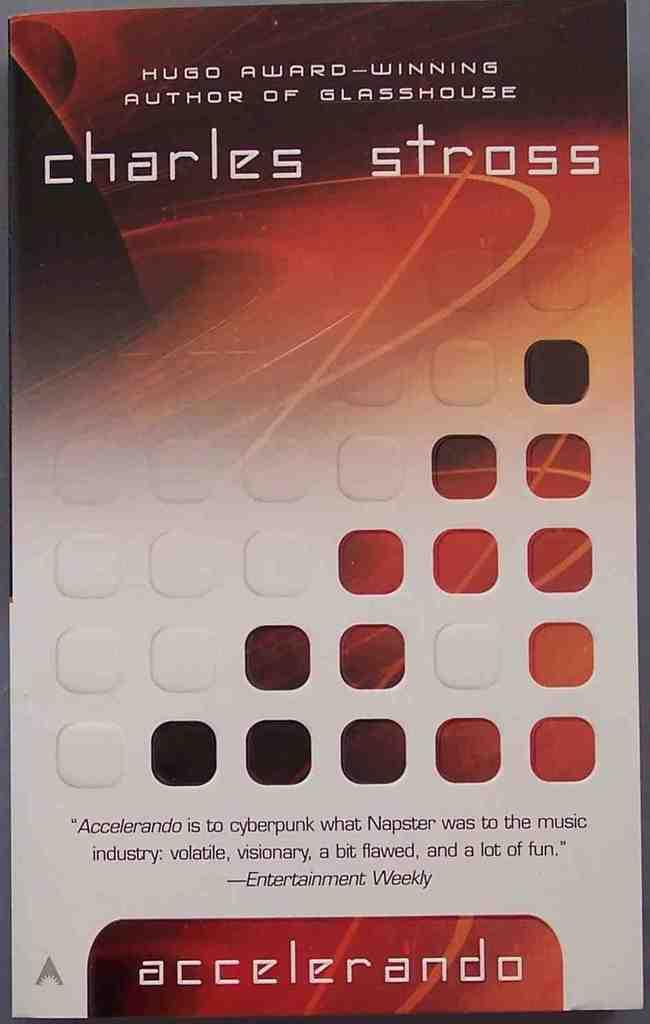<image>
Summarize the visual content of the image. A book by Hugo Award-winning Author of Glasshouse. 